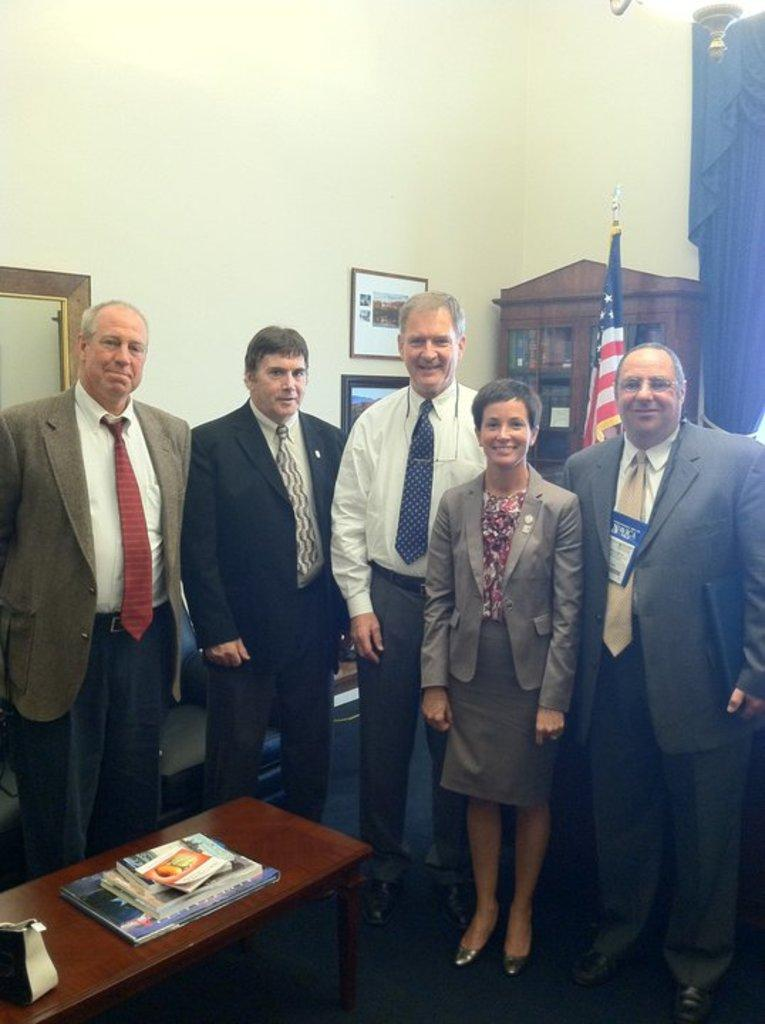What color is the wall in the image? The wall in the image is yellow. What can be seen hanging on the wall? There is a photo frame in the image. What is located near the wall? There is a rack in the image. What is attached to the rack? There is a flag in the image. How many people are standing in the image? There are five people standing in the image. What is in front of the people? There is a table in front of the people. What is on the table? There are books on the table. Can you tell me how many curtains are hanging on the wall in the image? There are no curtains present in the image. How do the people in the image plan to join the ongoing event? The image does not provide information about any ongoing event or the people's intentions to join it. 